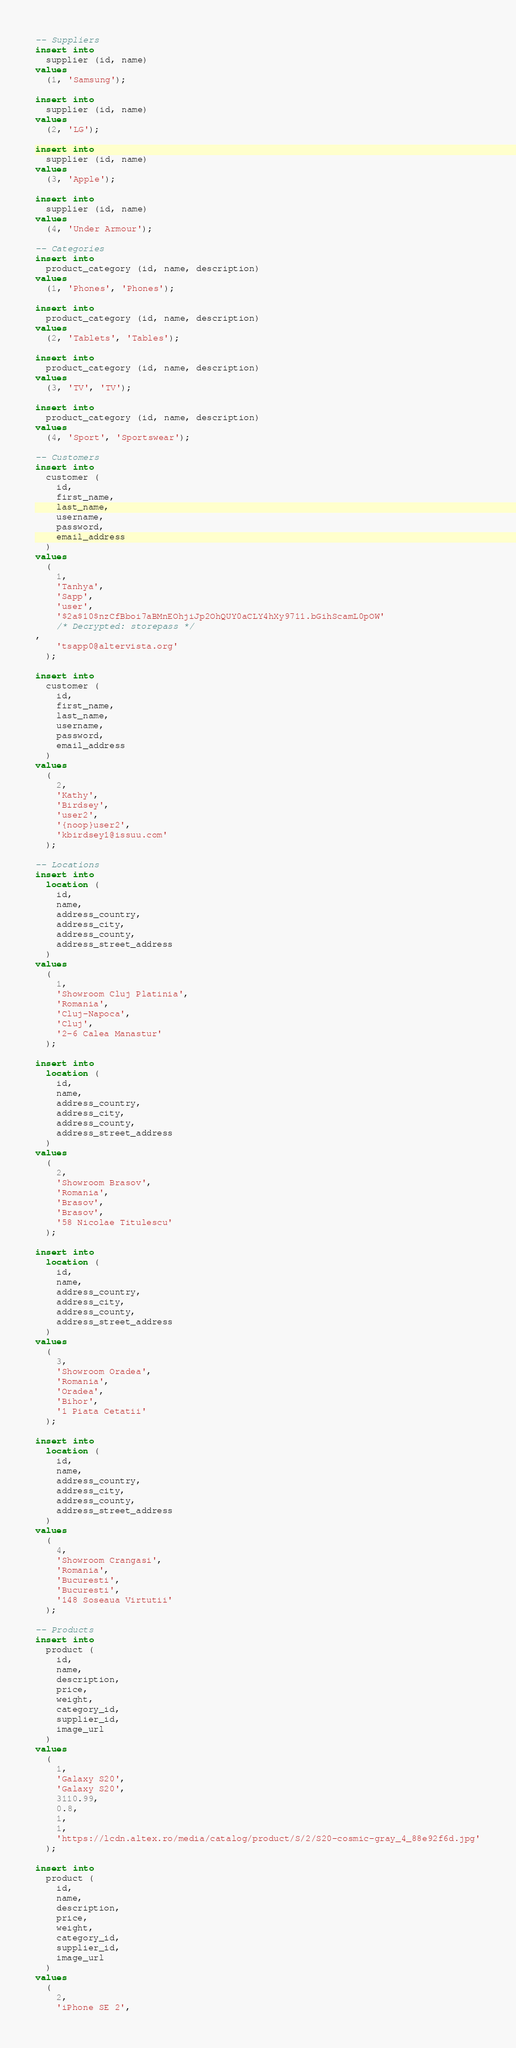Convert code to text. <code><loc_0><loc_0><loc_500><loc_500><_SQL_>-- Suppliers
insert into
  supplier (id, name)
values
  (1, 'Samsung');

insert into
  supplier (id, name)
values
  (2, 'LG');

insert into
  supplier (id, name)
values
  (3, 'Apple');

insert into
  supplier (id, name)
values
  (4, 'Under Armour');

-- Categories
insert into
  product_category (id, name, description)
values
  (1, 'Phones', 'Phones');

insert into
  product_category (id, name, description)
values
  (2, 'Tablets', 'Tables');

insert into
  product_category (id, name, description)
values
  (3, 'TV', 'TV');

insert into
  product_category (id, name, description)
values
  (4, 'Sport', 'Sportswear');

-- Customers
insert into
  customer (
    id,
    first_name,
    last_name,
    username,
    password,
    email_address
  )
values
  (
    1,
    'Tanhya',
    'Sapp',
    'user',
    '$2a$10$nzCfBboi7aBMnEOhjiJp2OhQUY0aCLY4hXy9711.bGihScamL0pOW'
    /* Decrypted: storepass */
,
    'tsapp0@altervista.org'
  );

insert into
  customer (
    id,
    first_name,
    last_name,
    username,
    password,
    email_address
  )
values
  (
    2,
    'Kathy',
    'Birdsey',
    'user2',
    '{noop}user2',
    'kbirdsey1@issuu.com'
  );

-- Locations
insert into
  location (
    id,
    name,
    address_country,
    address_city,
    address_county,
    address_street_address
  )
values
  (
    1,
    'Showroom Cluj Platinia',
    'Romania',
    'Cluj-Napoca',
    'Cluj',
    '2-6 Calea Manastur'
  );

insert into
  location (
    id,
    name,
    address_country,
    address_city,
    address_county,
    address_street_address
  )
values
  (
    2,
    'Showroom Brasov',
    'Romania',
    'Brasov',
    'Brasov',
    '58 Nicolae Titulescu'
  );

insert into
  location (
    id,
    name,
    address_country,
    address_city,
    address_county,
    address_street_address
  )
values
  (
    3,
    'Showroom Oradea',
    'Romania',
    'Oradea',
    'Bihor',
    '1 Piata Cetatii'
  );

insert into
  location (
    id,
    name,
    address_country,
    address_city,
    address_county,
    address_street_address
  )
values
  (
    4,
    'Showroom Crangasi',
    'Romania',
    'Bucuresti',
    'Bucuresti',
    '148 Soseaua Virtutii'
  );

-- Products
insert into
  product (
    id,
    name,
    description,
    price,
    weight,
    category_id,
    supplier_id,
    image_url
  )
values
  (
    1,
    'Galaxy S20',
    'Galaxy S20',
    3110.99,
    0.8,
    1,
    1,
    'https://lcdn.altex.ro/media/catalog/product/S/2/S20-cosmic-gray_4_88e92f6d.jpg'
  );

insert into
  product (
    id,
    name,
    description,
    price,
    weight,
    category_id,
    supplier_id,
    image_url
  )
values
  (
    2,
    'iPhone SE 2',</code> 